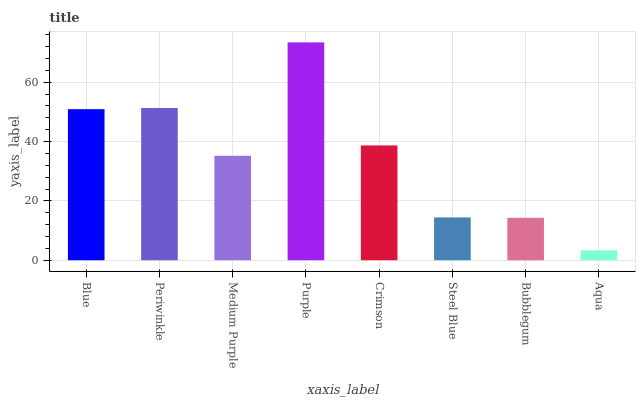Is Aqua the minimum?
Answer yes or no. Yes. Is Purple the maximum?
Answer yes or no. Yes. Is Periwinkle the minimum?
Answer yes or no. No. Is Periwinkle the maximum?
Answer yes or no. No. Is Periwinkle greater than Blue?
Answer yes or no. Yes. Is Blue less than Periwinkle?
Answer yes or no. Yes. Is Blue greater than Periwinkle?
Answer yes or no. No. Is Periwinkle less than Blue?
Answer yes or no. No. Is Crimson the high median?
Answer yes or no. Yes. Is Medium Purple the low median?
Answer yes or no. Yes. Is Aqua the high median?
Answer yes or no. No. Is Steel Blue the low median?
Answer yes or no. No. 